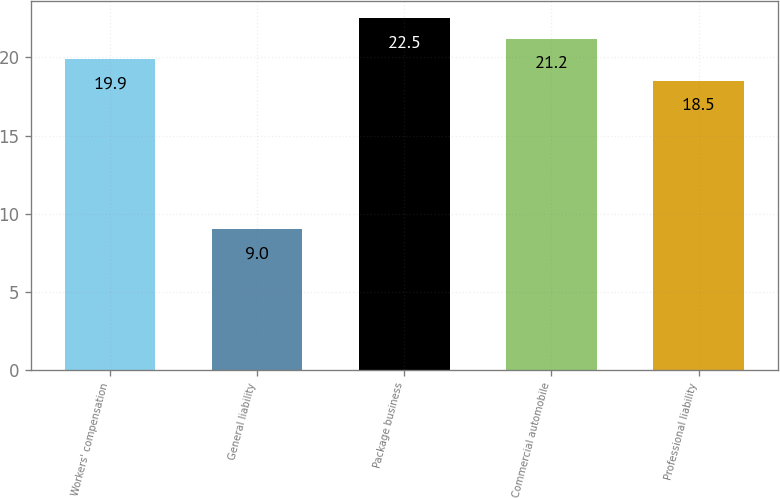Convert chart to OTSL. <chart><loc_0><loc_0><loc_500><loc_500><bar_chart><fcel>Workers' compensation<fcel>General liability<fcel>Package business<fcel>Commercial automobile<fcel>Professional liability<nl><fcel>19.9<fcel>9<fcel>22.5<fcel>21.2<fcel>18.5<nl></chart> 